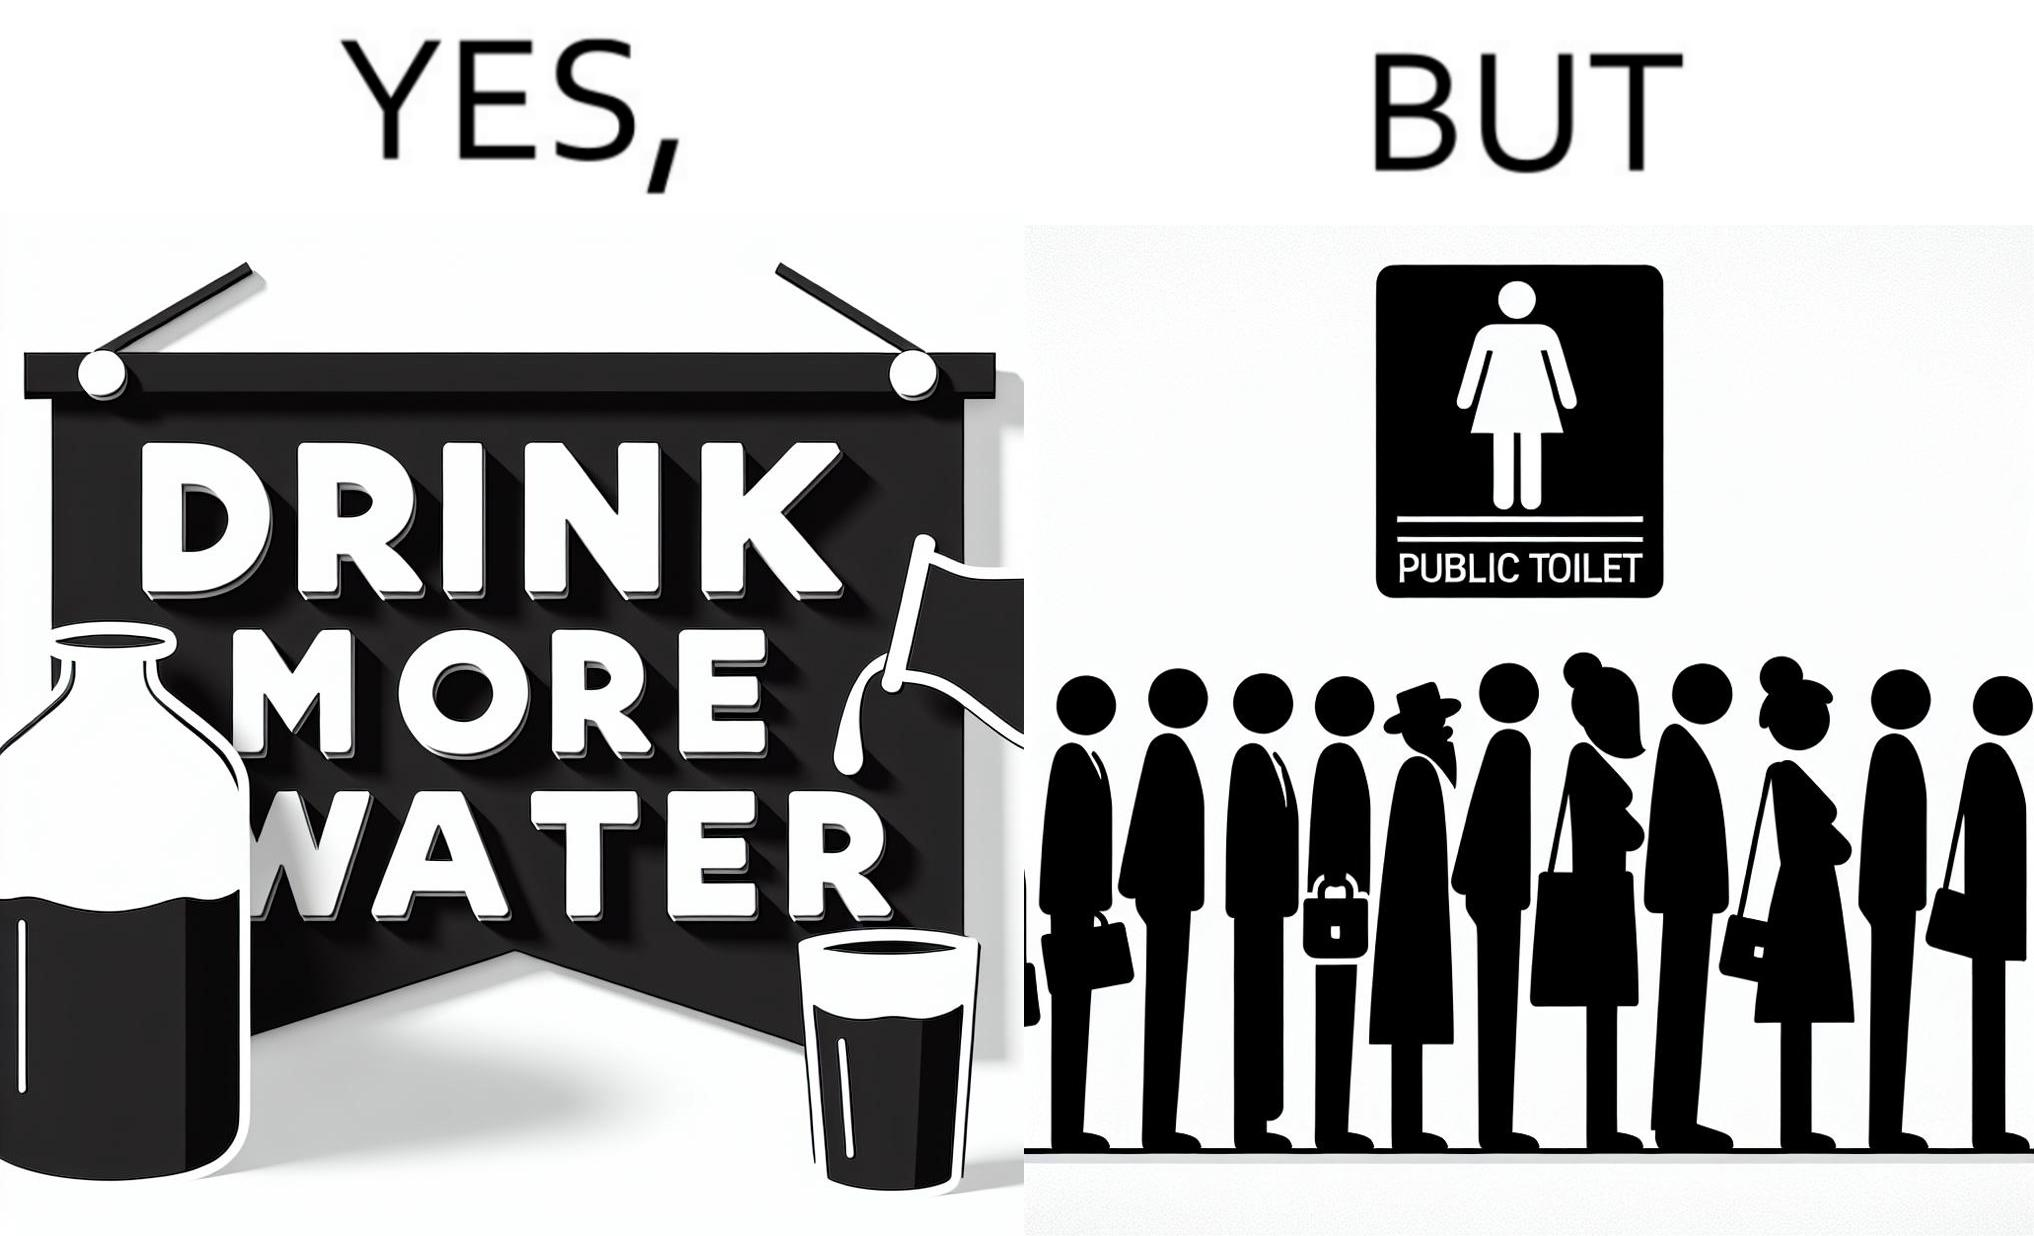Describe the contrast between the left and right parts of this image. In the left part of the image: A banner that says "Drink more water" with an image of a jug pouring water into a glass. In the right part of the image: a very long queue in front of the public toilet 